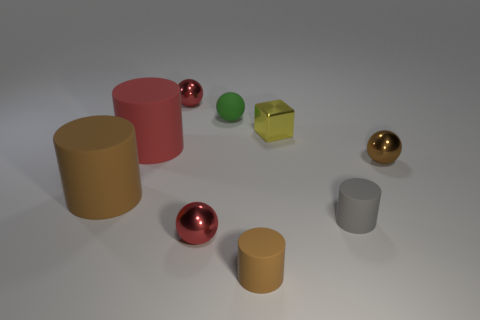Subtract all brown spheres. How many spheres are left? 3 Subtract 1 blocks. How many blocks are left? 0 Subtract all brown cylinders. How many cylinders are left? 2 Subtract all blocks. How many objects are left? 8 Add 1 big red objects. How many big red objects exist? 2 Subtract 0 cyan balls. How many objects are left? 9 Subtract all red cylinders. Subtract all green cubes. How many cylinders are left? 3 Subtract all brown spheres. How many blue cylinders are left? 0 Subtract all large matte objects. Subtract all red objects. How many objects are left? 4 Add 9 small gray things. How many small gray things are left? 10 